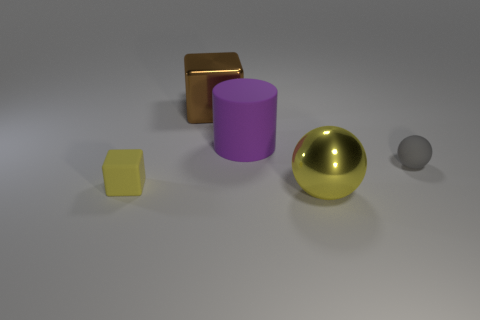Add 5 yellow blocks. How many objects exist? 10 Subtract all cylinders. How many objects are left? 4 Add 5 yellow shiny balls. How many yellow shiny balls are left? 6 Add 4 small purple balls. How many small purple balls exist? 4 Subtract 0 purple cubes. How many objects are left? 5 Subtract all large blocks. Subtract all big brown objects. How many objects are left? 3 